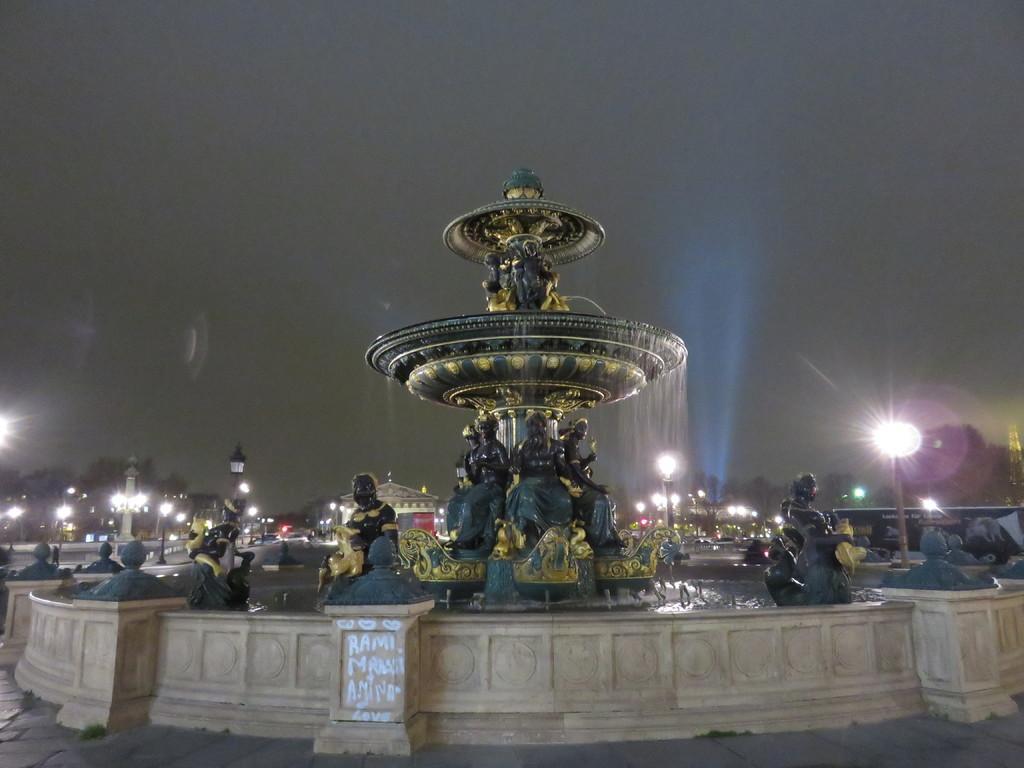Could you give a brief overview of what you see in this image? In this picture we can see a sculpture fountain and in front of the fountain there are some other sculptures. Behind the fountain, there are trees, buildings, poles with lights and the sky. 